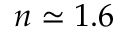<formula> <loc_0><loc_0><loc_500><loc_500>n \simeq 1 . 6</formula> 